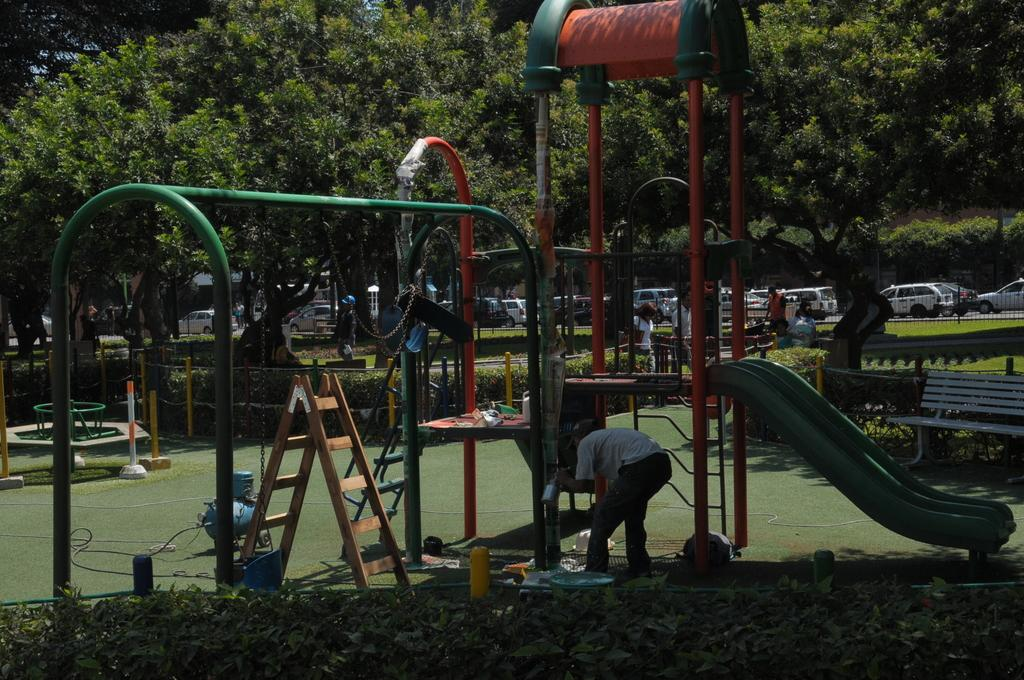What type of equipment can be seen in the image? There is playground equipment in the image. Are there any natural elements present in the image? Yes, there are plants and trees in the background of the image. What type of seating is available in the image? There is a bench in the image. Is there any barrier or enclosure visible in the image? Yes, there is a fence in the image. What else can be seen in the image besides the playground equipment and plants? There are vehicles and persons in the image. What type of cannon is present in the image? There is no cannon present in the image. What day of the week is depicted in the image? The image does not depict a specific day of the week; it is a still image. 